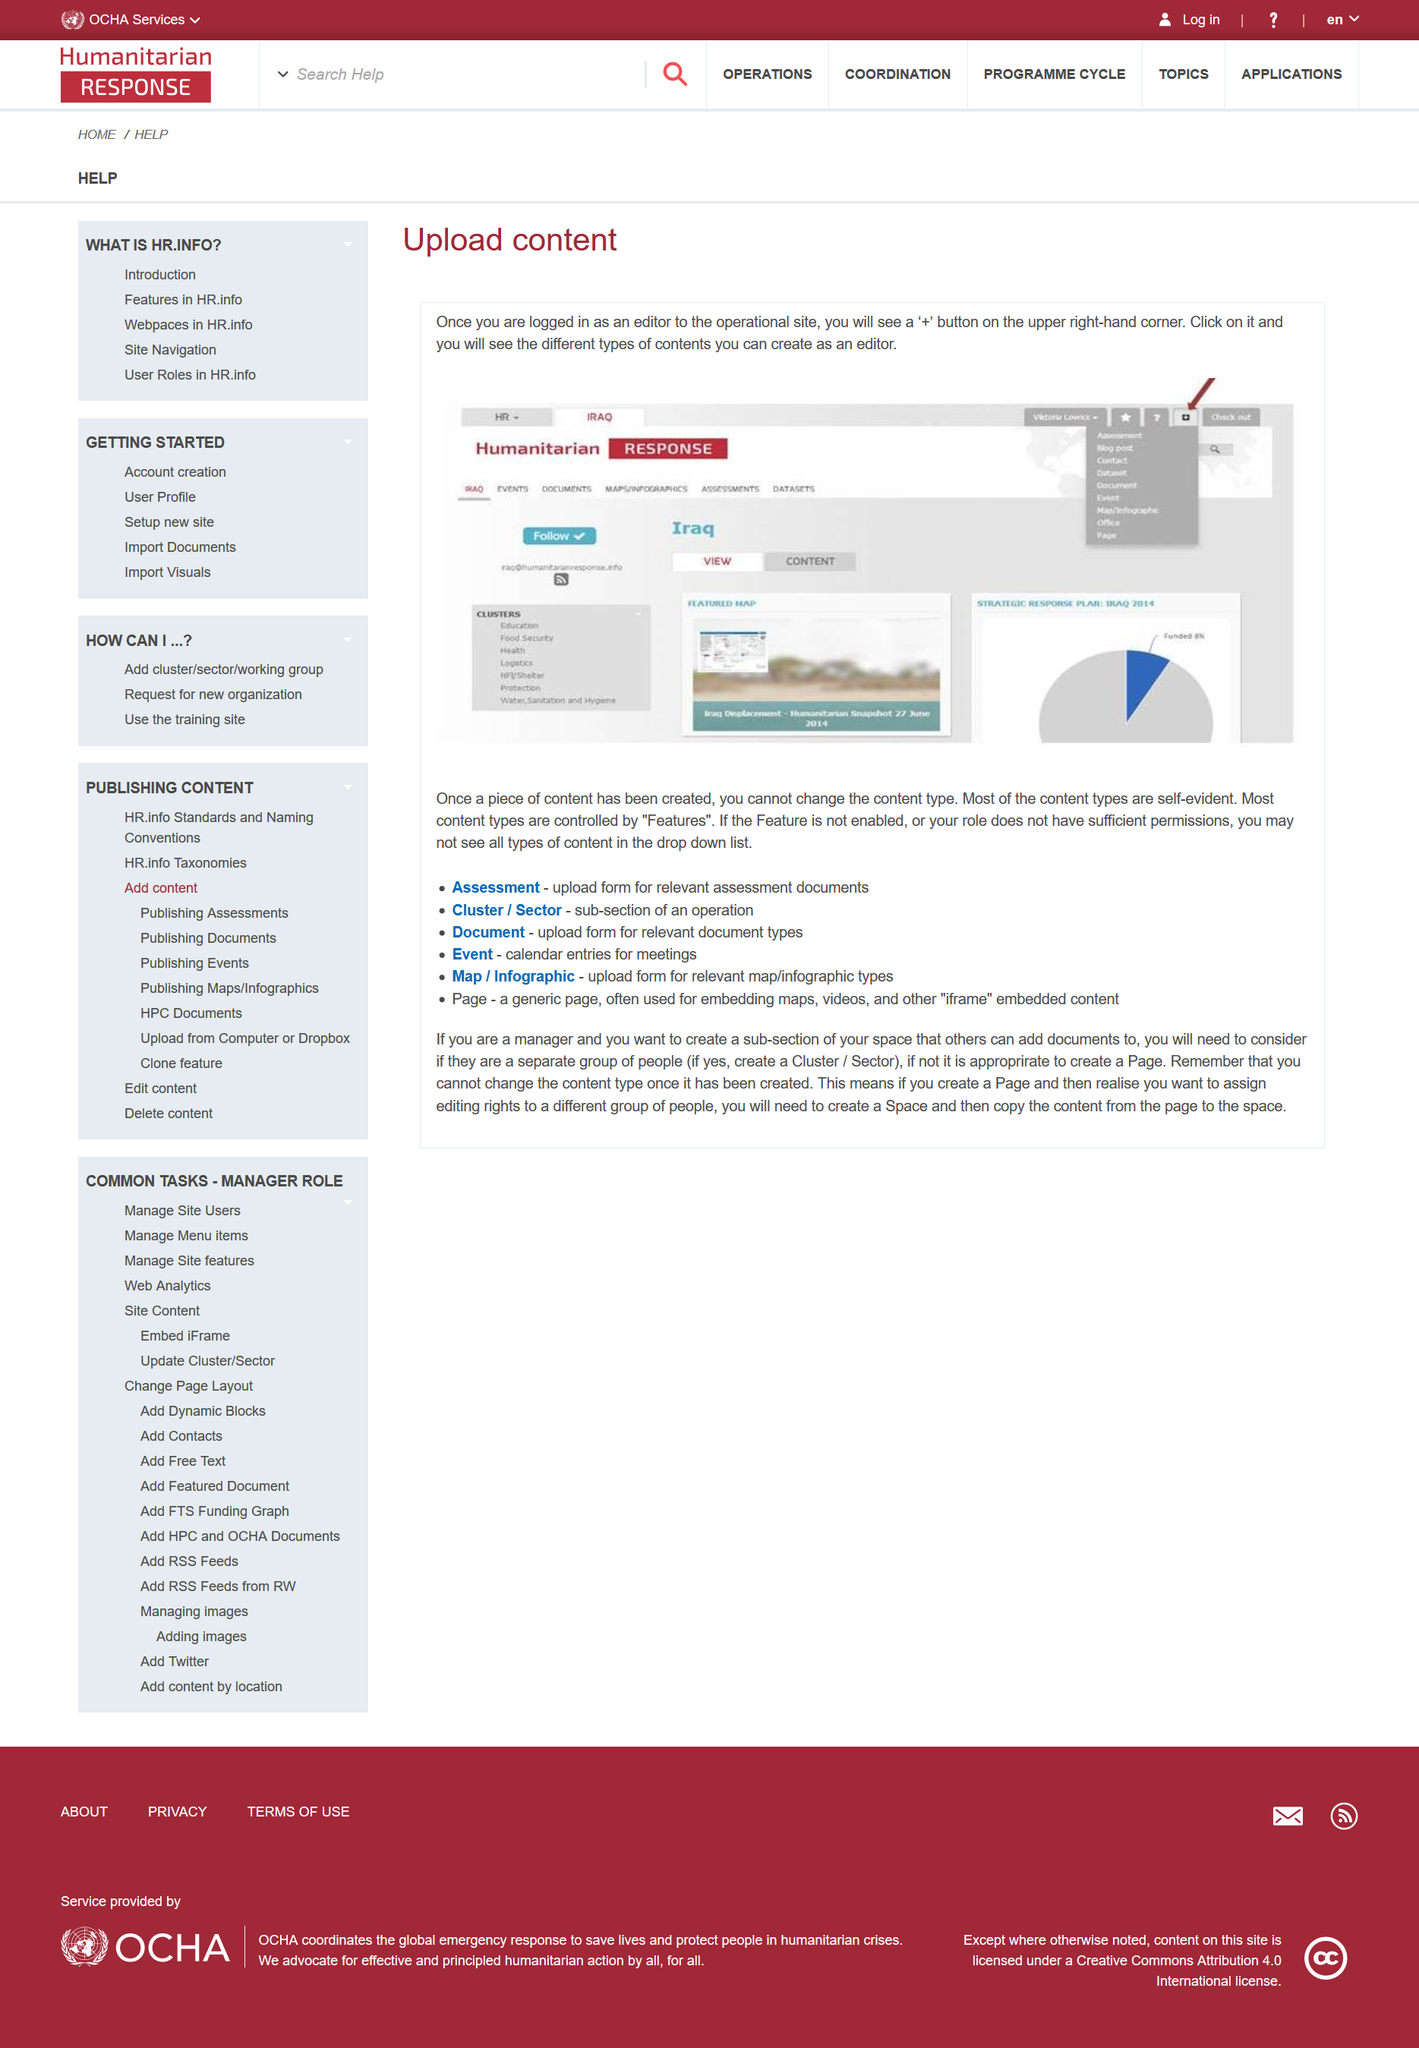Indicate a few pertinent items in this graphic. It is not possible to change the content type of a piece of content after it has been created. On the Humanitarian Response page, I can click on the '+' button located in the upper right-hand corner to view the types of content that I, as an editor, can create. The content is not available because the feature is not enabled or your role does not have sufficient permissions. 